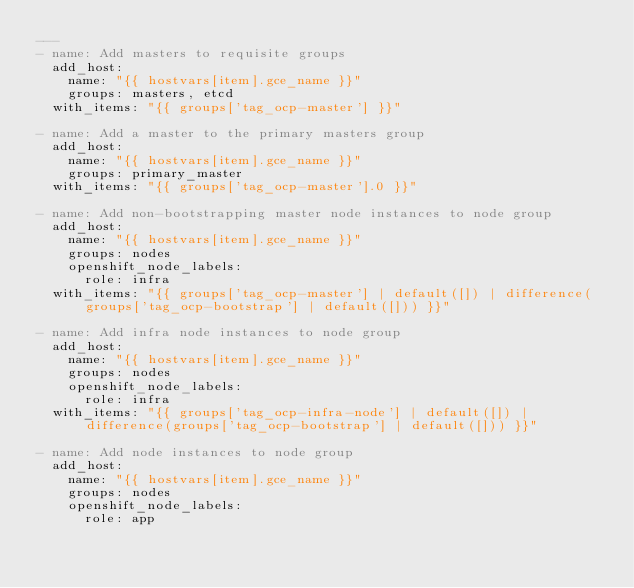<code> <loc_0><loc_0><loc_500><loc_500><_YAML_>---
- name: Add masters to requisite groups
  add_host:
    name: "{{ hostvars[item].gce_name }}"
    groups: masters, etcd
  with_items: "{{ groups['tag_ocp-master'] }}"

- name: Add a master to the primary masters group
  add_host:
    name: "{{ hostvars[item].gce_name }}"
    groups: primary_master
  with_items: "{{ groups['tag_ocp-master'].0 }}"

- name: Add non-bootstrapping master node instances to node group
  add_host:
    name: "{{ hostvars[item].gce_name }}"
    groups: nodes
    openshift_node_labels:
      role: infra
  with_items: "{{ groups['tag_ocp-master'] | default([]) | difference(groups['tag_ocp-bootstrap'] | default([])) }}"

- name: Add infra node instances to node group
  add_host:
    name: "{{ hostvars[item].gce_name }}"
    groups: nodes
    openshift_node_labels:
      role: infra
  with_items: "{{ groups['tag_ocp-infra-node'] | default([]) | difference(groups['tag_ocp-bootstrap'] | default([])) }}"

- name: Add node instances to node group
  add_host:
    name: "{{ hostvars[item].gce_name }}"
    groups: nodes
    openshift_node_labels:
      role: app</code> 